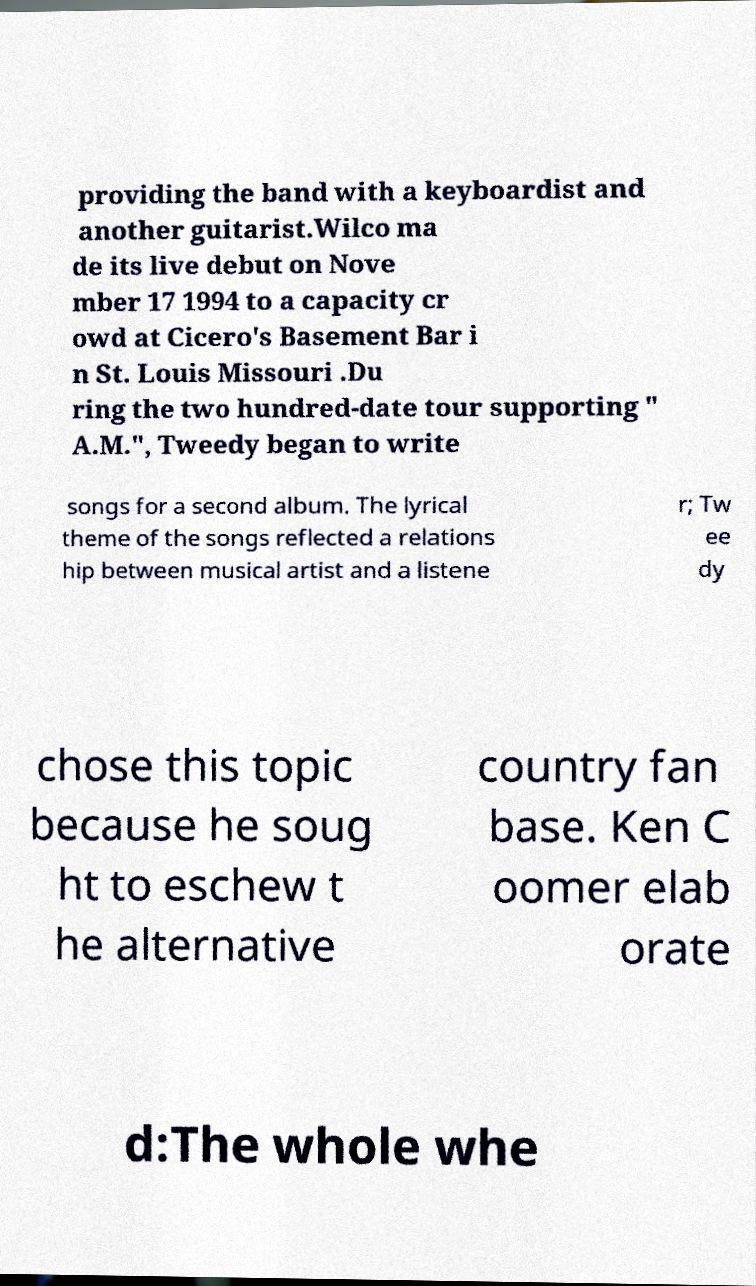Please read and relay the text visible in this image. What does it say? providing the band with a keyboardist and another guitarist.Wilco ma de its live debut on Nove mber 17 1994 to a capacity cr owd at Cicero's Basement Bar i n St. Louis Missouri .Du ring the two hundred-date tour supporting " A.M.", Tweedy began to write songs for a second album. The lyrical theme of the songs reflected a relations hip between musical artist and a listene r; Tw ee dy chose this topic because he soug ht to eschew t he alternative country fan base. Ken C oomer elab orate d:The whole whe 